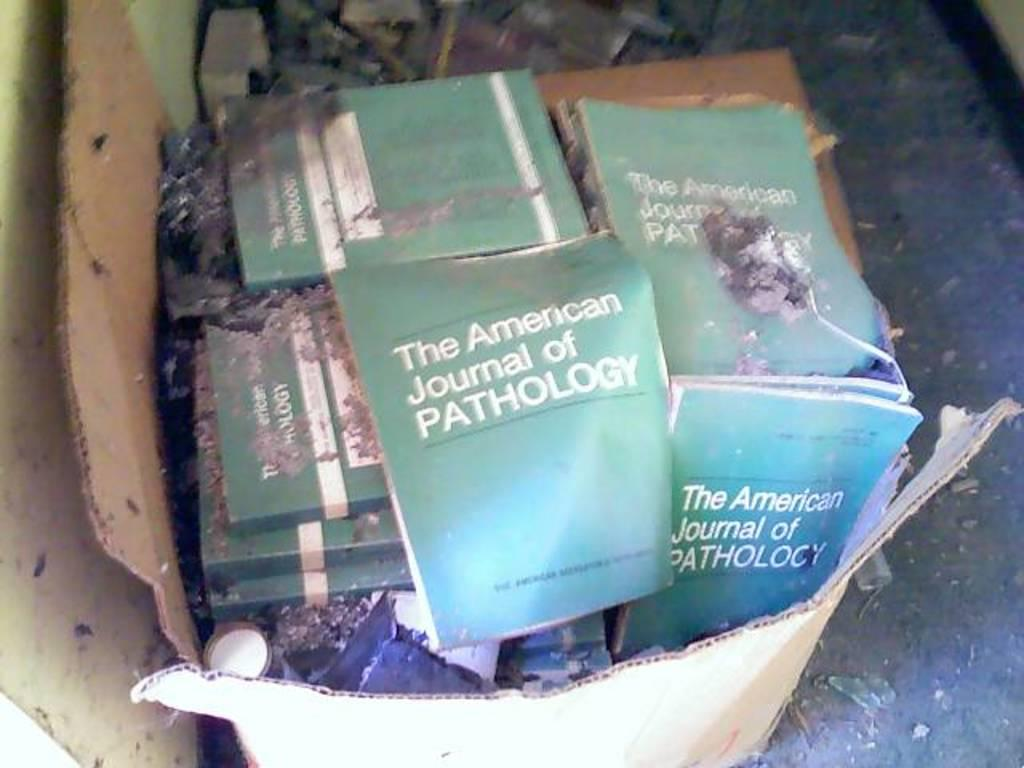<image>
Offer a succinct explanation of the picture presented. An old box filled with green books titled The American Journal of Pathology. 